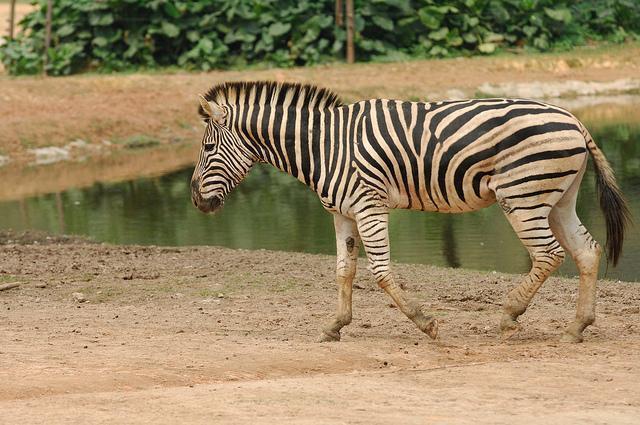How many people are not wearing glasses?
Give a very brief answer. 0. 